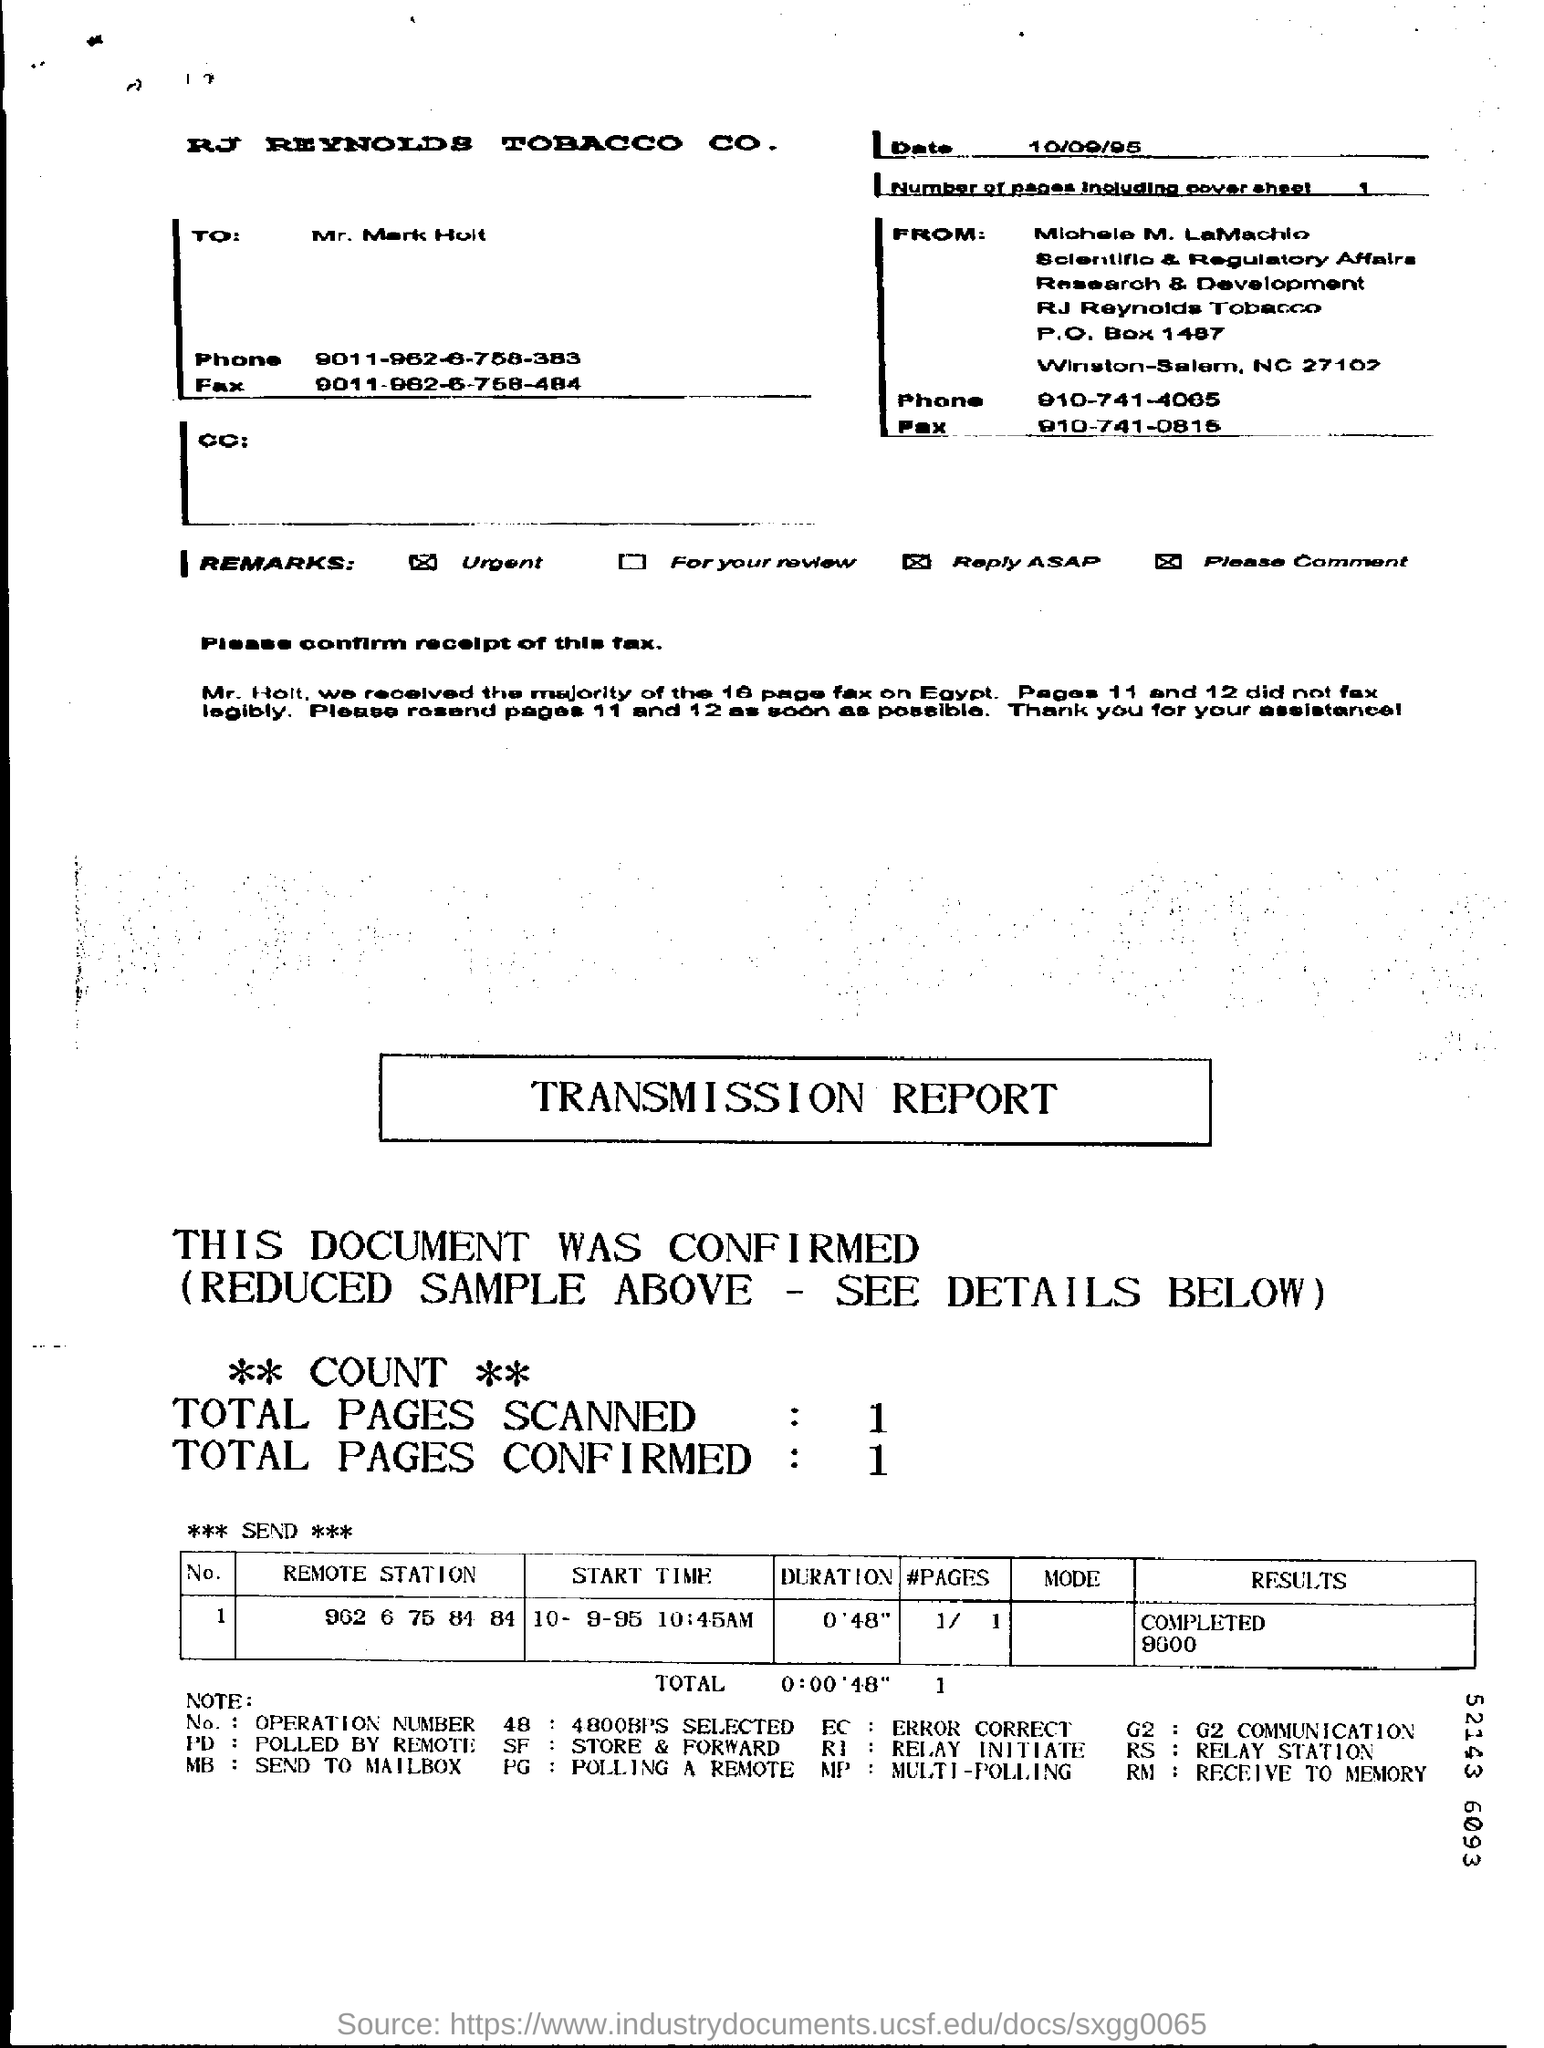What is the date on the Fax?
Provide a succinct answer. 10/09/95. What is the "Duration" for "Remote Station" "902 6 75 84 84"?
Your answer should be compact. 0'48". What is the "Start Time" for "Remote Station" "902 6 75 84 84"?
Your answer should be very brief. 10- 9-95 10:45AM. What is the "Results" for "Remote Station" "902 6 75 84 84"?
Provide a short and direct response. Completed 9600. What is the Total Pages Scanned?
Provide a succinct answer. 1. What is the Total Pages Confirmed?
Your response must be concise. 1. 